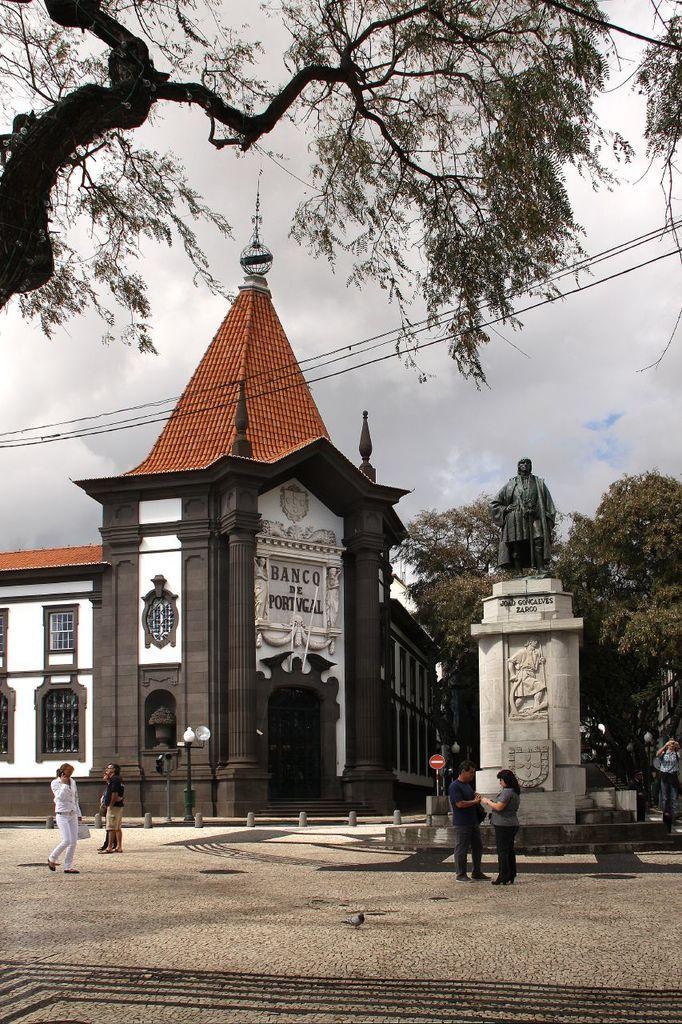Could you give a brief overview of what you see in this image? In this image I can see few people are standing. On the right side of the image I can see few sculptures, few trees and on the left side of the image I can see a building, a pole and a light on it. I can also see something is written on the building. In the centre of the image I can see a red colour sign board. On the top side of the image I can see few wires, clouds, the sky and a tree. 